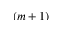Convert formula to latex. <formula><loc_0><loc_0><loc_500><loc_500>( m + 1 )</formula> 